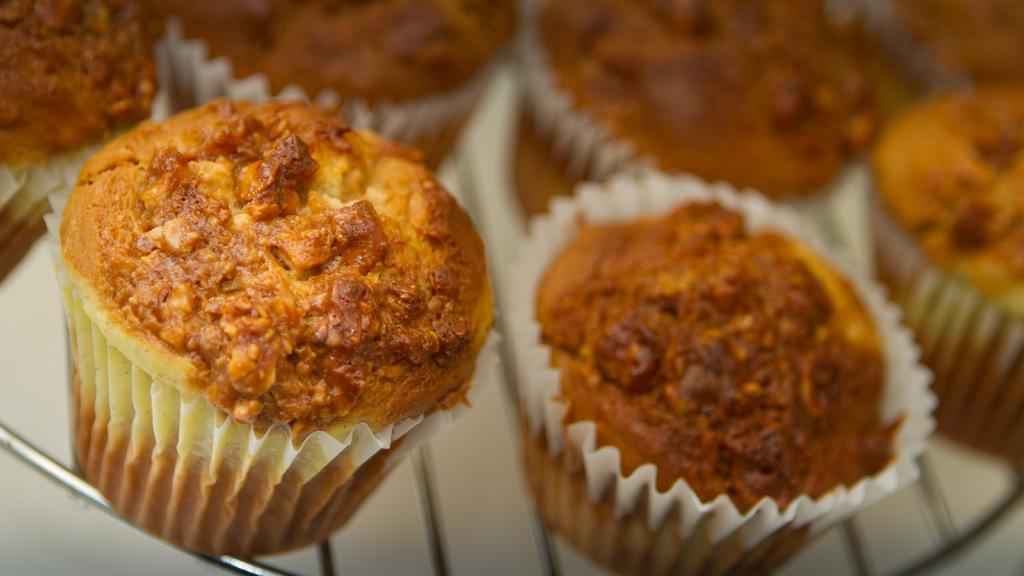What type of food can be seen in the image? There are cupcakes in the image. Where are the cupcakes located? The cupcakes are on a steel grill. How many brothers are present in the image? There are no brothers mentioned or depicted in the image. What type of wilderness can be seen in the image? There is no wilderness present in the image; it features cupcakes on a steel grill. 